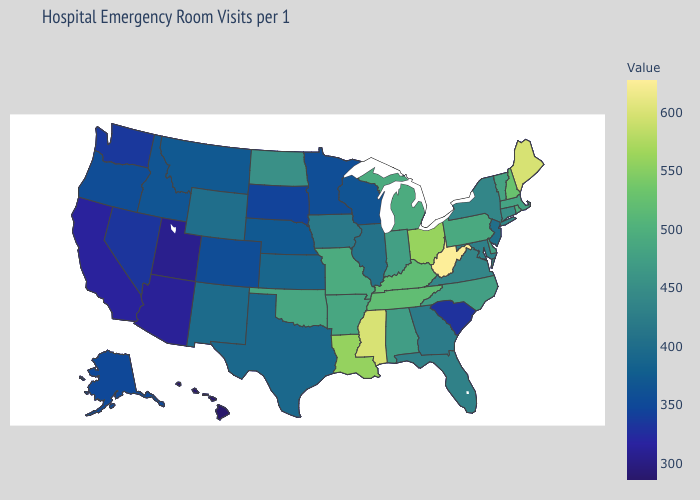Among the states that border Montana , does North Dakota have the lowest value?
Answer briefly. No. Does West Virginia have the highest value in the USA?
Keep it brief. Yes. Does New Jersey have the lowest value in the Northeast?
Answer briefly. Yes. Does the map have missing data?
Short answer required. No. Does Hawaii have a higher value than Texas?
Be succinct. No. 